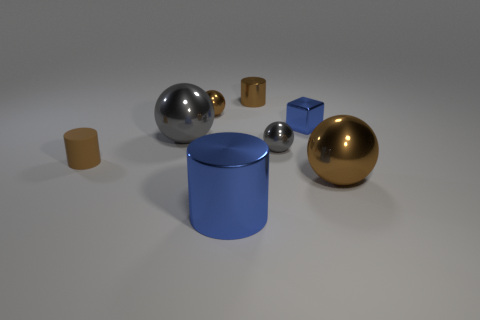How many big blue shiny objects have the same shape as the small matte object?
Give a very brief answer. 1. What is the material of the small brown object that is the same shape as the large gray object?
Provide a short and direct response. Metal. There is a small cylinder that is right of the blue thing that is on the left side of the cylinder that is behind the tiny rubber thing; what is its color?
Keep it short and to the point. Brown. Is the tiny brown cylinder in front of the large gray metallic ball made of the same material as the large brown thing?
Give a very brief answer. No. What number of other objects are there of the same material as the large gray thing?
Provide a succinct answer. 6. What is the material of the other cylinder that is the same size as the brown metal cylinder?
Your answer should be very brief. Rubber. There is a blue shiny object that is in front of the cube; is it the same shape as the brown object left of the tiny brown sphere?
Make the answer very short. Yes. What shape is the gray shiny thing that is the same size as the matte thing?
Your response must be concise. Sphere. Is the brown cylinder that is on the right side of the brown matte object made of the same material as the brown sphere that is in front of the large gray shiny ball?
Your response must be concise. Yes. There is a brown shiny sphere on the left side of the large brown thing; is there a sphere on the left side of it?
Ensure brevity in your answer.  Yes. 